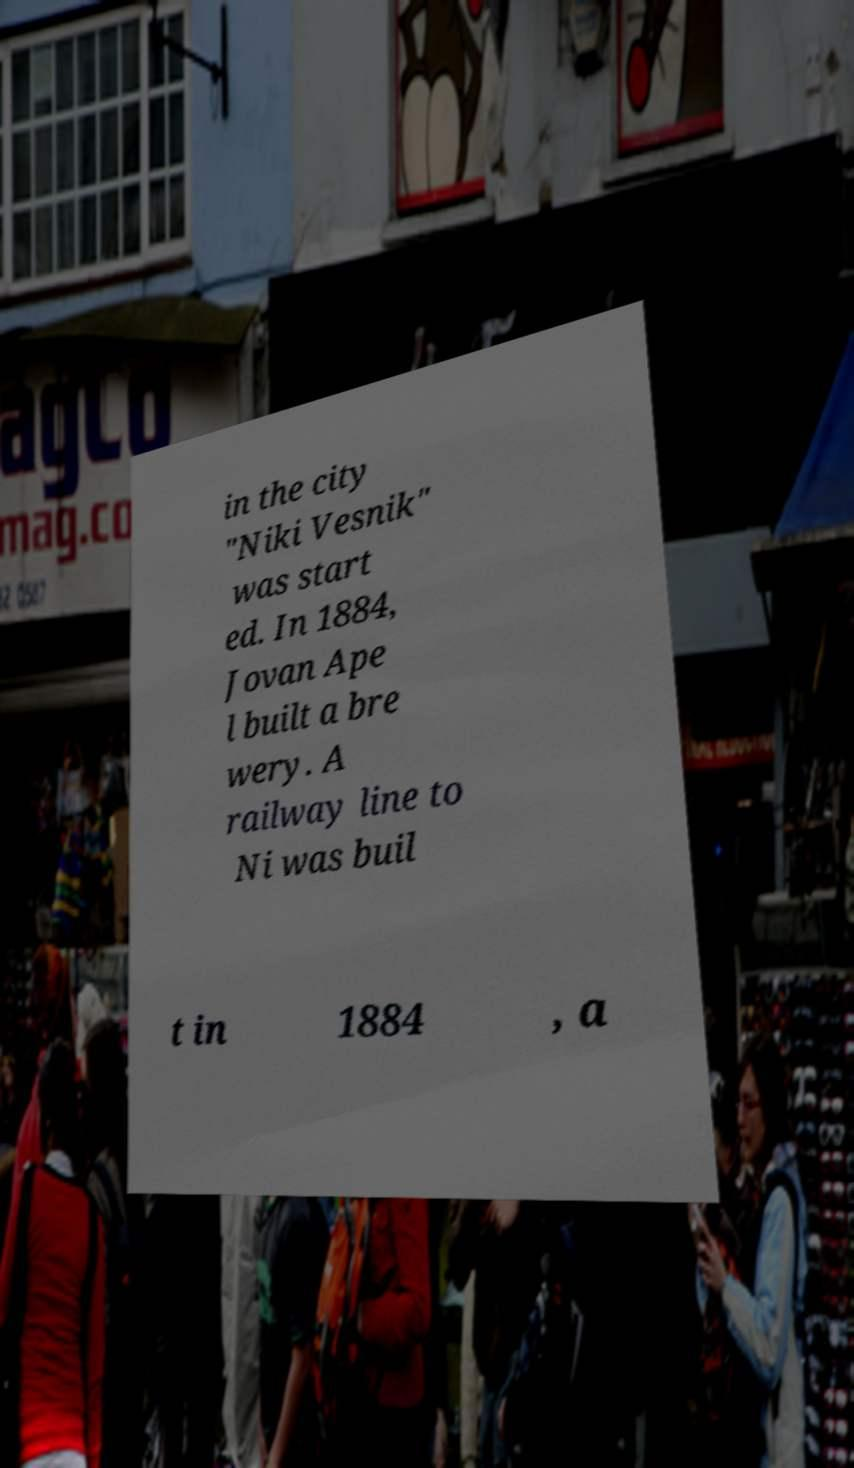What messages or text are displayed in this image? I need them in a readable, typed format. in the city "Niki Vesnik" was start ed. In 1884, Jovan Ape l built a bre wery. A railway line to Ni was buil t in 1884 , a 